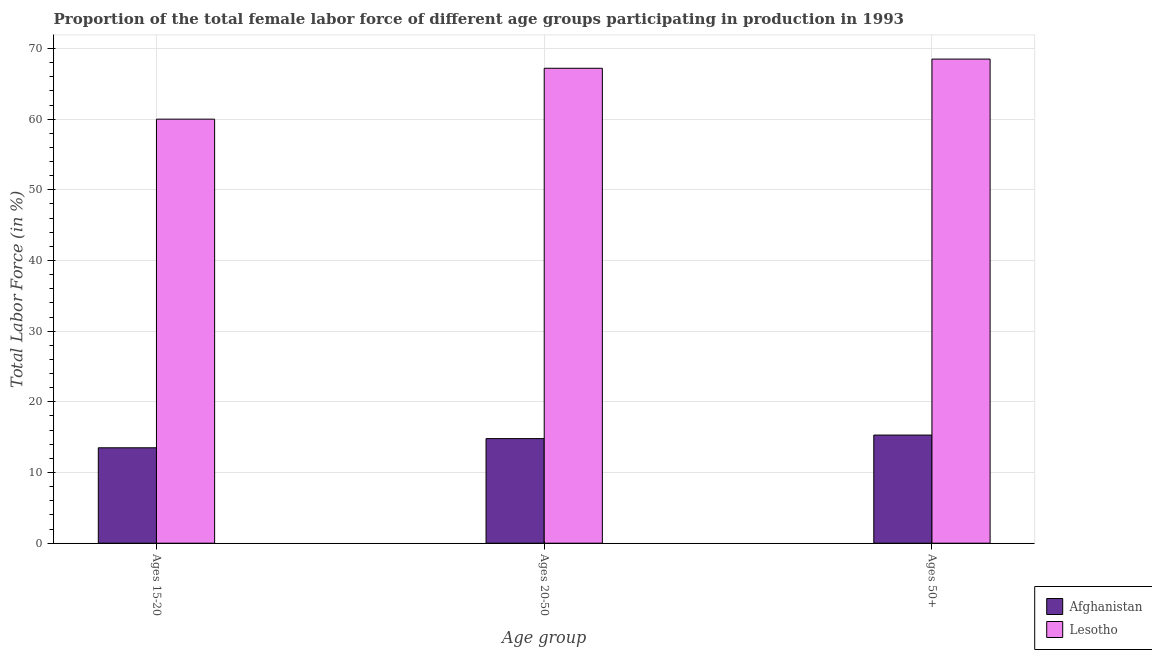Are the number of bars on each tick of the X-axis equal?
Offer a terse response. Yes. How many bars are there on the 1st tick from the right?
Ensure brevity in your answer.  2. What is the label of the 3rd group of bars from the left?
Make the answer very short. Ages 50+. What is the percentage of female labor force above age 50 in Lesotho?
Keep it short and to the point. 68.5. Across all countries, what is the maximum percentage of female labor force above age 50?
Make the answer very short. 68.5. Across all countries, what is the minimum percentage of female labor force above age 50?
Your response must be concise. 15.3. In which country was the percentage of female labor force within the age group 15-20 maximum?
Your response must be concise. Lesotho. In which country was the percentage of female labor force within the age group 20-50 minimum?
Ensure brevity in your answer.  Afghanistan. What is the total percentage of female labor force within the age group 20-50 in the graph?
Give a very brief answer. 82. What is the difference between the percentage of female labor force above age 50 in Afghanistan and that in Lesotho?
Ensure brevity in your answer.  -53.2. What is the difference between the percentage of female labor force above age 50 in Afghanistan and the percentage of female labor force within the age group 20-50 in Lesotho?
Provide a succinct answer. -51.9. What is the average percentage of female labor force within the age group 20-50 per country?
Offer a very short reply. 41. What is the difference between the percentage of female labor force above age 50 and percentage of female labor force within the age group 15-20 in Afghanistan?
Give a very brief answer. 1.8. What is the ratio of the percentage of female labor force within the age group 20-50 in Lesotho to that in Afghanistan?
Keep it short and to the point. 4.54. Is the difference between the percentage of female labor force within the age group 15-20 in Lesotho and Afghanistan greater than the difference between the percentage of female labor force within the age group 20-50 in Lesotho and Afghanistan?
Offer a very short reply. No. What is the difference between the highest and the second highest percentage of female labor force within the age group 15-20?
Your response must be concise. 46.5. What is the difference between the highest and the lowest percentage of female labor force within the age group 20-50?
Provide a short and direct response. 52.4. What does the 2nd bar from the left in Ages 15-20 represents?
Your answer should be compact. Lesotho. What does the 2nd bar from the right in Ages 50+ represents?
Provide a short and direct response. Afghanistan. Is it the case that in every country, the sum of the percentage of female labor force within the age group 15-20 and percentage of female labor force within the age group 20-50 is greater than the percentage of female labor force above age 50?
Provide a short and direct response. Yes. How many bars are there?
Your response must be concise. 6. How many countries are there in the graph?
Offer a terse response. 2. What is the difference between two consecutive major ticks on the Y-axis?
Offer a terse response. 10. Are the values on the major ticks of Y-axis written in scientific E-notation?
Your answer should be compact. No. Does the graph contain any zero values?
Ensure brevity in your answer.  No. Does the graph contain grids?
Offer a very short reply. Yes. What is the title of the graph?
Ensure brevity in your answer.  Proportion of the total female labor force of different age groups participating in production in 1993. Does "Algeria" appear as one of the legend labels in the graph?
Your response must be concise. No. What is the label or title of the X-axis?
Make the answer very short. Age group. What is the Total Labor Force (in %) of Afghanistan in Ages 20-50?
Your answer should be very brief. 14.8. What is the Total Labor Force (in %) of Lesotho in Ages 20-50?
Provide a succinct answer. 67.2. What is the Total Labor Force (in %) in Afghanistan in Ages 50+?
Offer a terse response. 15.3. What is the Total Labor Force (in %) of Lesotho in Ages 50+?
Provide a succinct answer. 68.5. Across all Age group, what is the maximum Total Labor Force (in %) of Afghanistan?
Keep it short and to the point. 15.3. Across all Age group, what is the maximum Total Labor Force (in %) in Lesotho?
Offer a terse response. 68.5. Across all Age group, what is the minimum Total Labor Force (in %) in Lesotho?
Your answer should be compact. 60. What is the total Total Labor Force (in %) in Afghanistan in the graph?
Your response must be concise. 43.6. What is the total Total Labor Force (in %) of Lesotho in the graph?
Your answer should be very brief. 195.7. What is the difference between the Total Labor Force (in %) of Afghanistan in Ages 15-20 and that in Ages 20-50?
Your answer should be compact. -1.3. What is the difference between the Total Labor Force (in %) in Lesotho in Ages 15-20 and that in Ages 20-50?
Keep it short and to the point. -7.2. What is the difference between the Total Labor Force (in %) in Lesotho in Ages 15-20 and that in Ages 50+?
Make the answer very short. -8.5. What is the difference between the Total Labor Force (in %) in Lesotho in Ages 20-50 and that in Ages 50+?
Make the answer very short. -1.3. What is the difference between the Total Labor Force (in %) in Afghanistan in Ages 15-20 and the Total Labor Force (in %) in Lesotho in Ages 20-50?
Ensure brevity in your answer.  -53.7. What is the difference between the Total Labor Force (in %) in Afghanistan in Ages 15-20 and the Total Labor Force (in %) in Lesotho in Ages 50+?
Provide a succinct answer. -55. What is the difference between the Total Labor Force (in %) of Afghanistan in Ages 20-50 and the Total Labor Force (in %) of Lesotho in Ages 50+?
Make the answer very short. -53.7. What is the average Total Labor Force (in %) in Afghanistan per Age group?
Make the answer very short. 14.53. What is the average Total Labor Force (in %) in Lesotho per Age group?
Provide a succinct answer. 65.23. What is the difference between the Total Labor Force (in %) in Afghanistan and Total Labor Force (in %) in Lesotho in Ages 15-20?
Ensure brevity in your answer.  -46.5. What is the difference between the Total Labor Force (in %) of Afghanistan and Total Labor Force (in %) of Lesotho in Ages 20-50?
Your answer should be compact. -52.4. What is the difference between the Total Labor Force (in %) in Afghanistan and Total Labor Force (in %) in Lesotho in Ages 50+?
Provide a short and direct response. -53.2. What is the ratio of the Total Labor Force (in %) in Afghanistan in Ages 15-20 to that in Ages 20-50?
Provide a short and direct response. 0.91. What is the ratio of the Total Labor Force (in %) in Lesotho in Ages 15-20 to that in Ages 20-50?
Ensure brevity in your answer.  0.89. What is the ratio of the Total Labor Force (in %) in Afghanistan in Ages 15-20 to that in Ages 50+?
Your answer should be very brief. 0.88. What is the ratio of the Total Labor Force (in %) in Lesotho in Ages 15-20 to that in Ages 50+?
Provide a succinct answer. 0.88. What is the ratio of the Total Labor Force (in %) of Afghanistan in Ages 20-50 to that in Ages 50+?
Provide a short and direct response. 0.97. What is the difference between the highest and the second highest Total Labor Force (in %) of Lesotho?
Provide a succinct answer. 1.3. What is the difference between the highest and the lowest Total Labor Force (in %) of Afghanistan?
Provide a short and direct response. 1.8. 